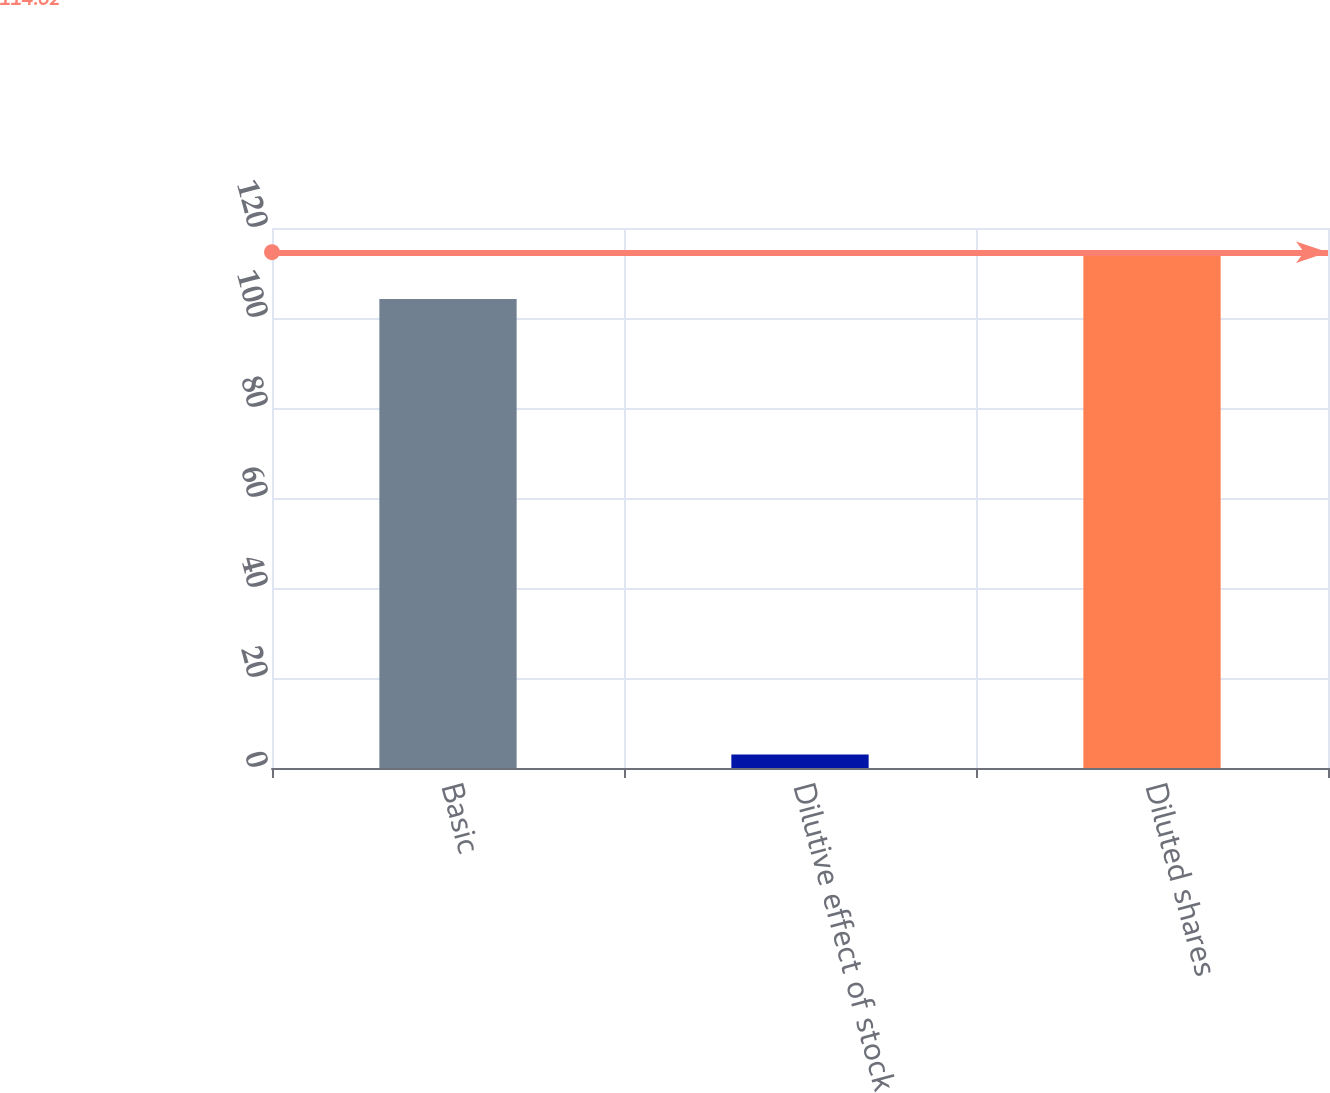Convert chart. <chart><loc_0><loc_0><loc_500><loc_500><bar_chart><fcel>Basic<fcel>Dilutive effect of stock<fcel>Diluted shares<nl><fcel>104.2<fcel>3<fcel>114.62<nl></chart> 